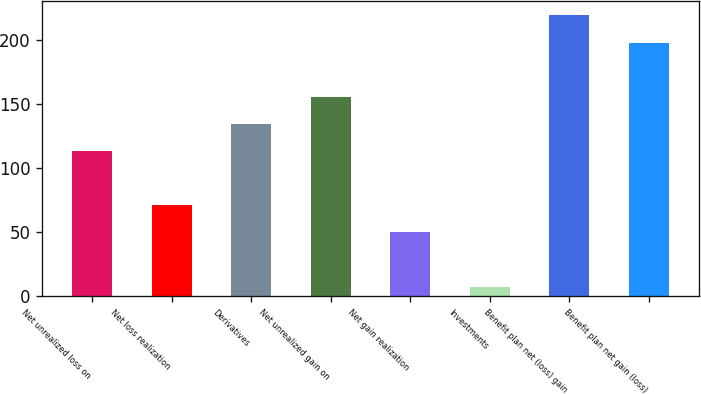<chart> <loc_0><loc_0><loc_500><loc_500><bar_chart><fcel>Net unrealized loss on<fcel>Net loss realization<fcel>Derivatives<fcel>Net unrealized gain on<fcel>Net gain realization<fcel>Investments<fcel>Benefit plan net (loss) gain<fcel>Benefit plan net gain (loss)<nl><fcel>113.3<fcel>71.02<fcel>134.44<fcel>155.58<fcel>49.88<fcel>7.6<fcel>219<fcel>197.86<nl></chart> 